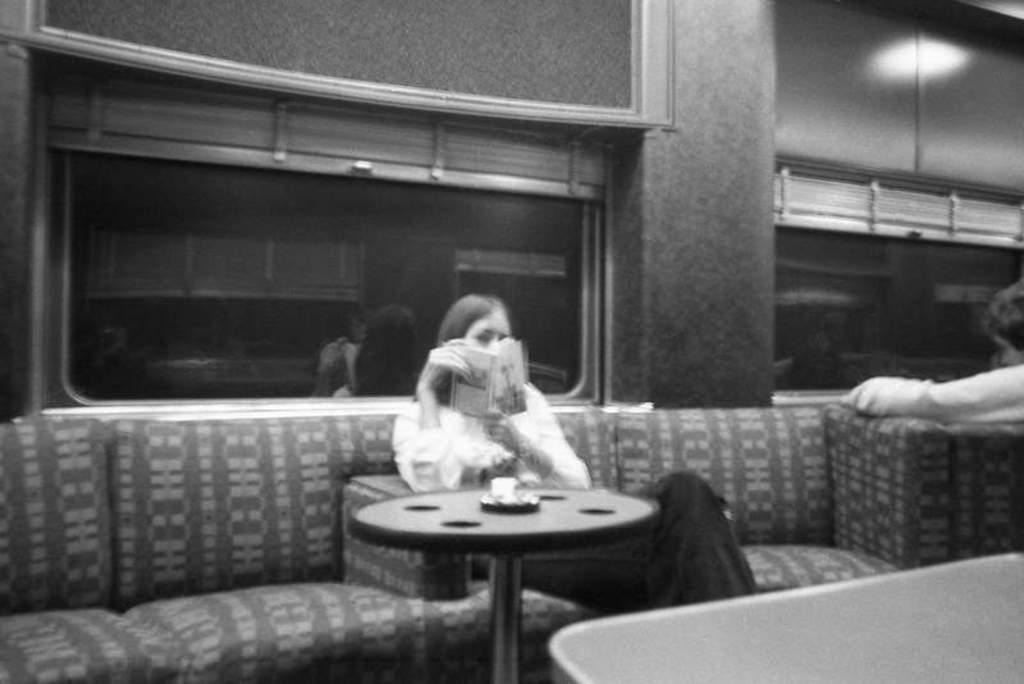What is the color scheme of the image? The image is black and white. What is the woman in the image doing? The woman is sitting on a sofa and reading a book. Are there any architectural features visible in the image? Yes, there are window glasses in the image. What type of committee is meeting in the image? There is no committee meeting in the image; it features a woman sitting on a sofa and reading a book. 